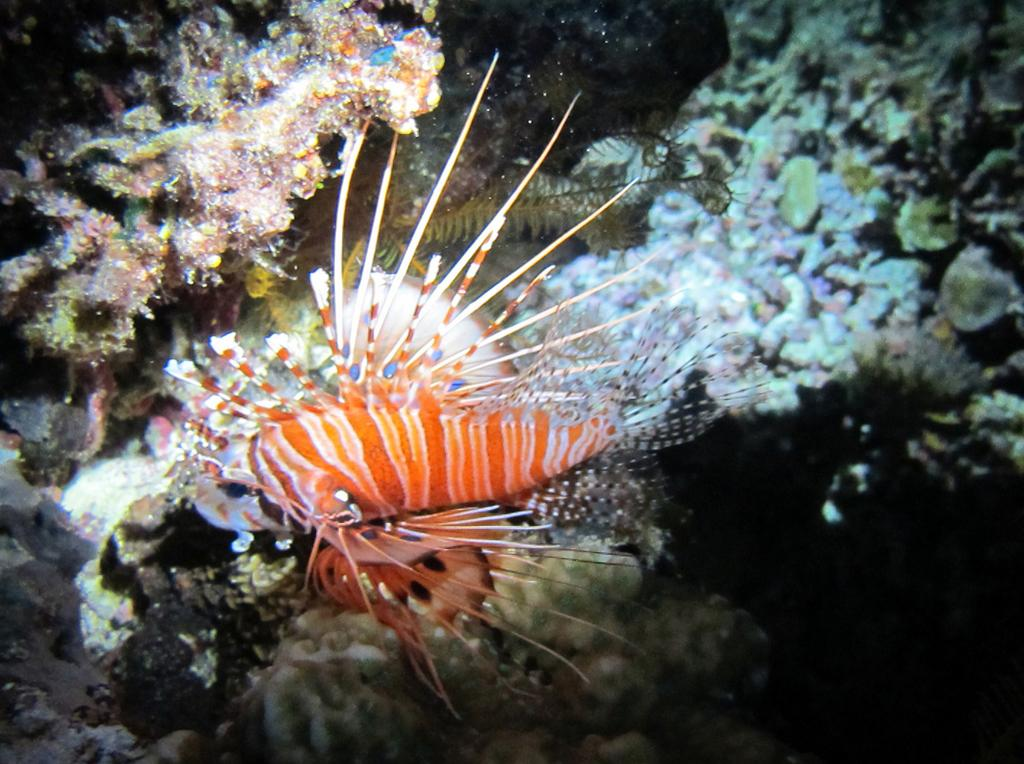What type of plants are visible in the image? There are sea plants in the image. What marine animal can be seen in the image? There is a lionfish in the image. What type of chicken is being rubbed on the sea plants in the image? There is no chicken present in the image, and the sea plants are not being rubbed on anything. 